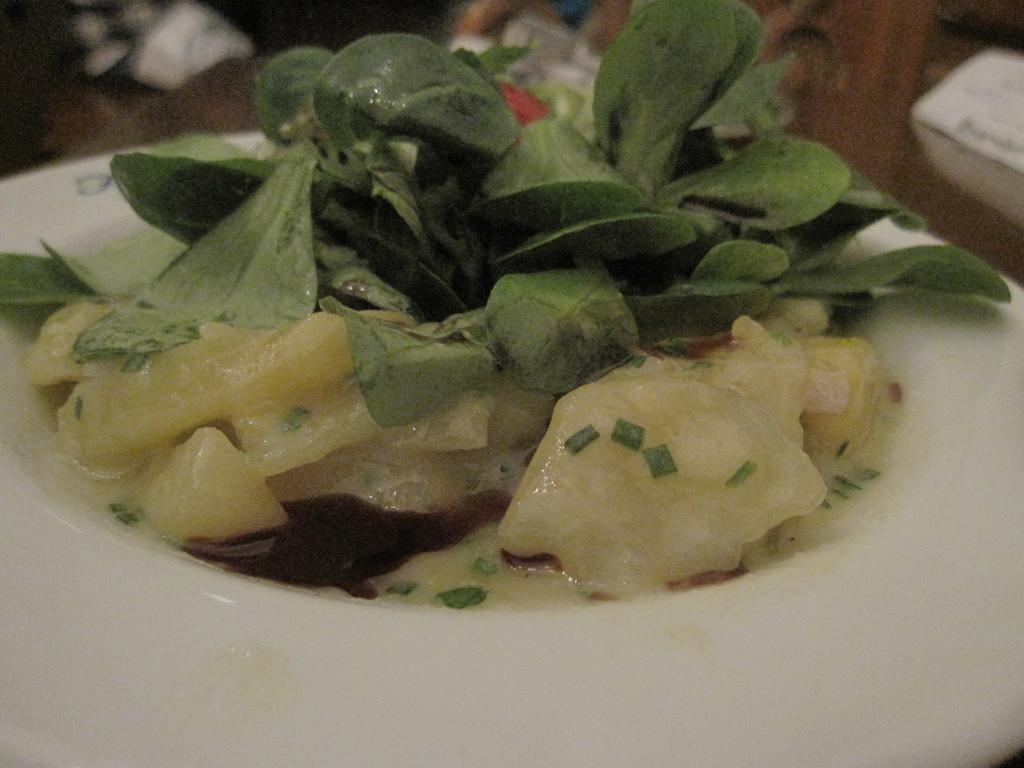What is on the plate in the image? There is a food item on a plate in the image. Can you describe the setting in which the plate is located? There is a table in the background of the image. What type of flowers are arranged around the oatmeal in the image? There is no oatmeal or flowers present in the image. 